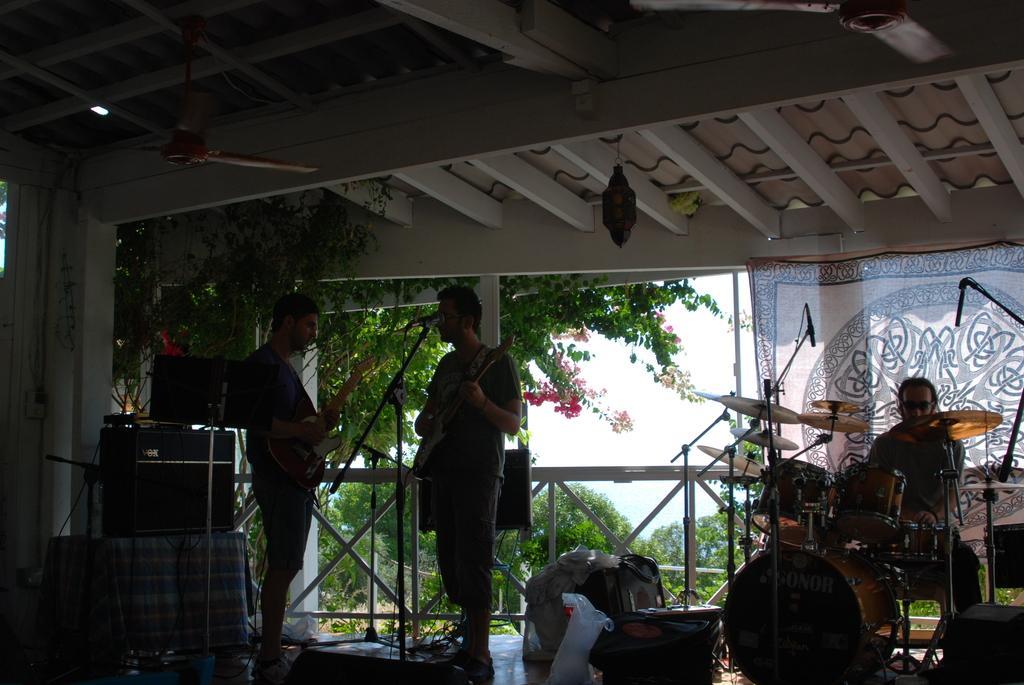How would you summarize this image in a sentence or two? In this image, we can see two people playing guitar and on the right, there is a person sitting and we can see musical instruments. In the background, there are trees, fence and to the top, we can see a fan attached to roof. 